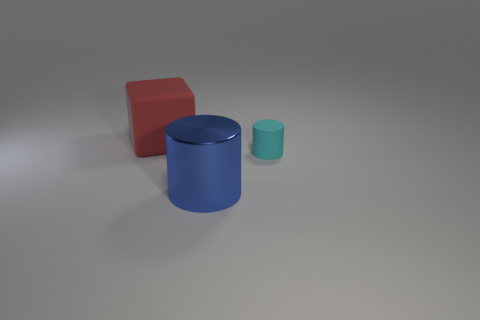Add 1 red objects. How many objects exist? 4 Subtract all cylinders. How many objects are left? 1 Subtract all green things. Subtract all large cubes. How many objects are left? 2 Add 1 blue metallic objects. How many blue metallic objects are left? 2 Add 1 big matte cubes. How many big matte cubes exist? 2 Subtract 0 green spheres. How many objects are left? 3 